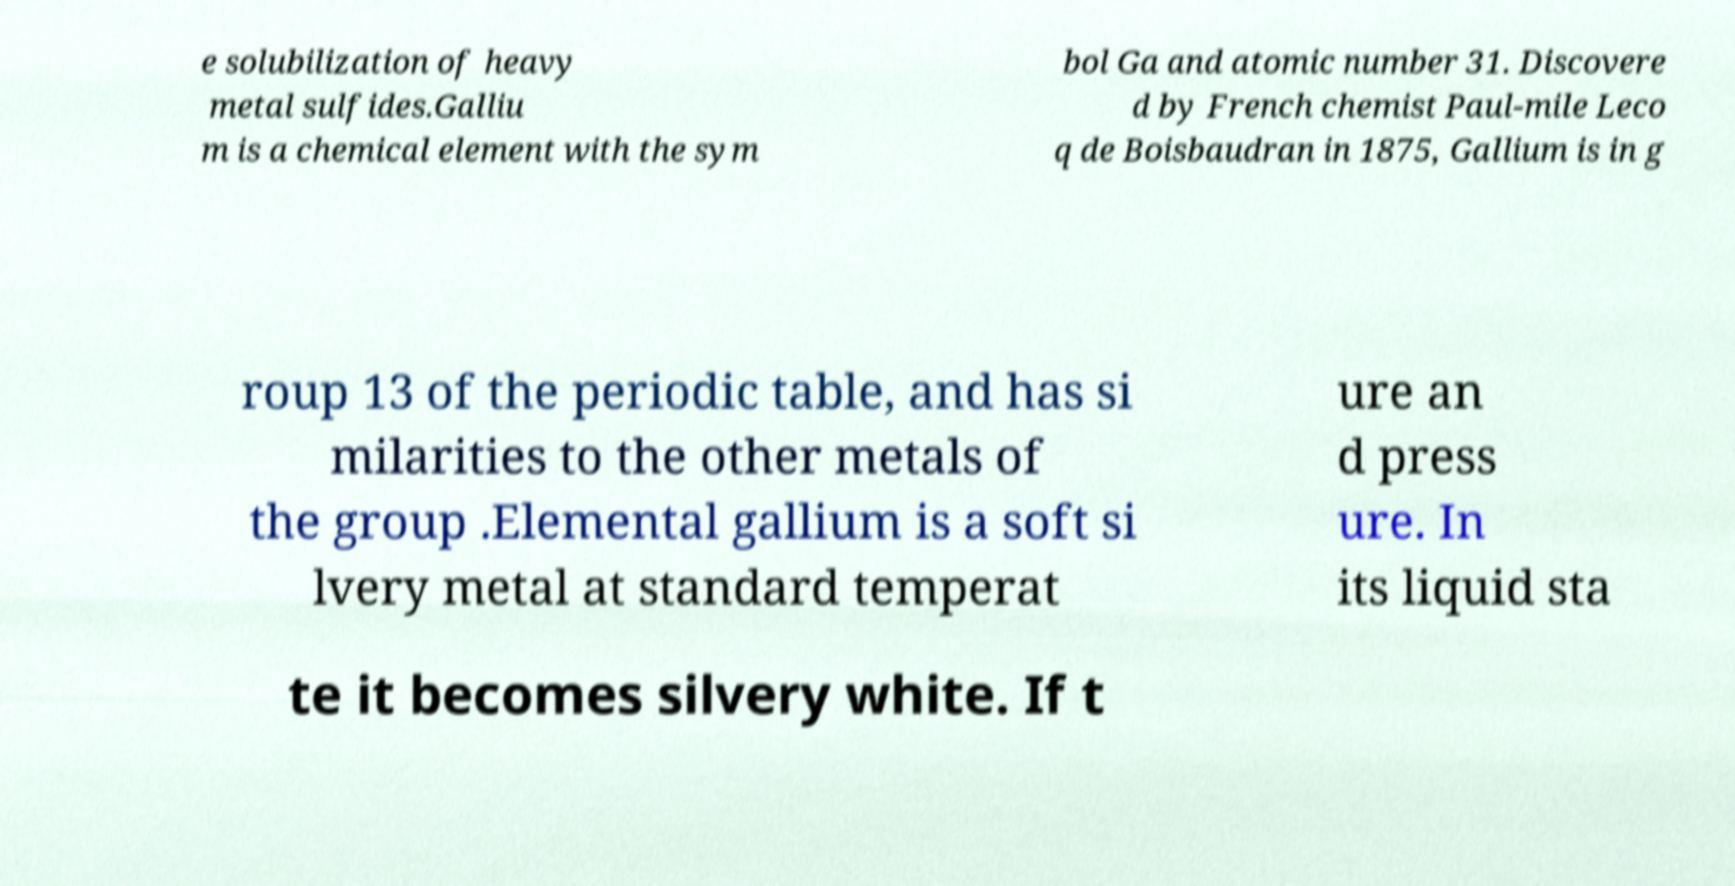Can you read and provide the text displayed in the image?This photo seems to have some interesting text. Can you extract and type it out for me? e solubilization of heavy metal sulfides.Galliu m is a chemical element with the sym bol Ga and atomic number 31. Discovere d by French chemist Paul-mile Leco q de Boisbaudran in 1875, Gallium is in g roup 13 of the periodic table, and has si milarities to the other metals of the group .Elemental gallium is a soft si lvery metal at standard temperat ure an d press ure. In its liquid sta te it becomes silvery white. If t 